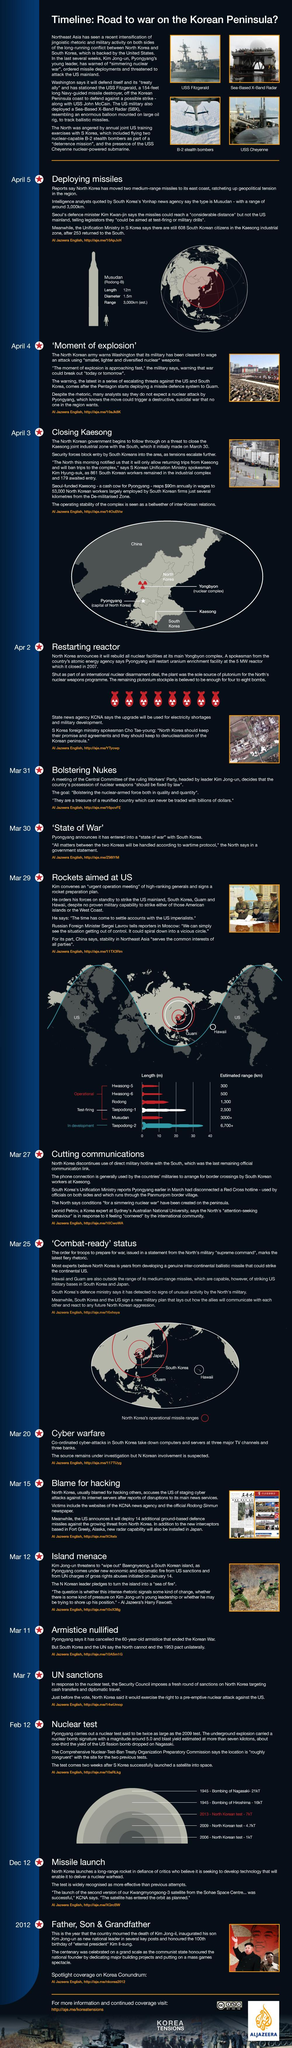Who was the leader of North Korea before Kim Jong-un?
Answer the question with a short phrase. Kim Jong-il What was the blast yield of the atomic bomb dropped on Hiroshima? 16kT What is the capital of North Korea? Pyongyang Which year was the atom bomb dropped on Nagasaki by the United States? 1945 